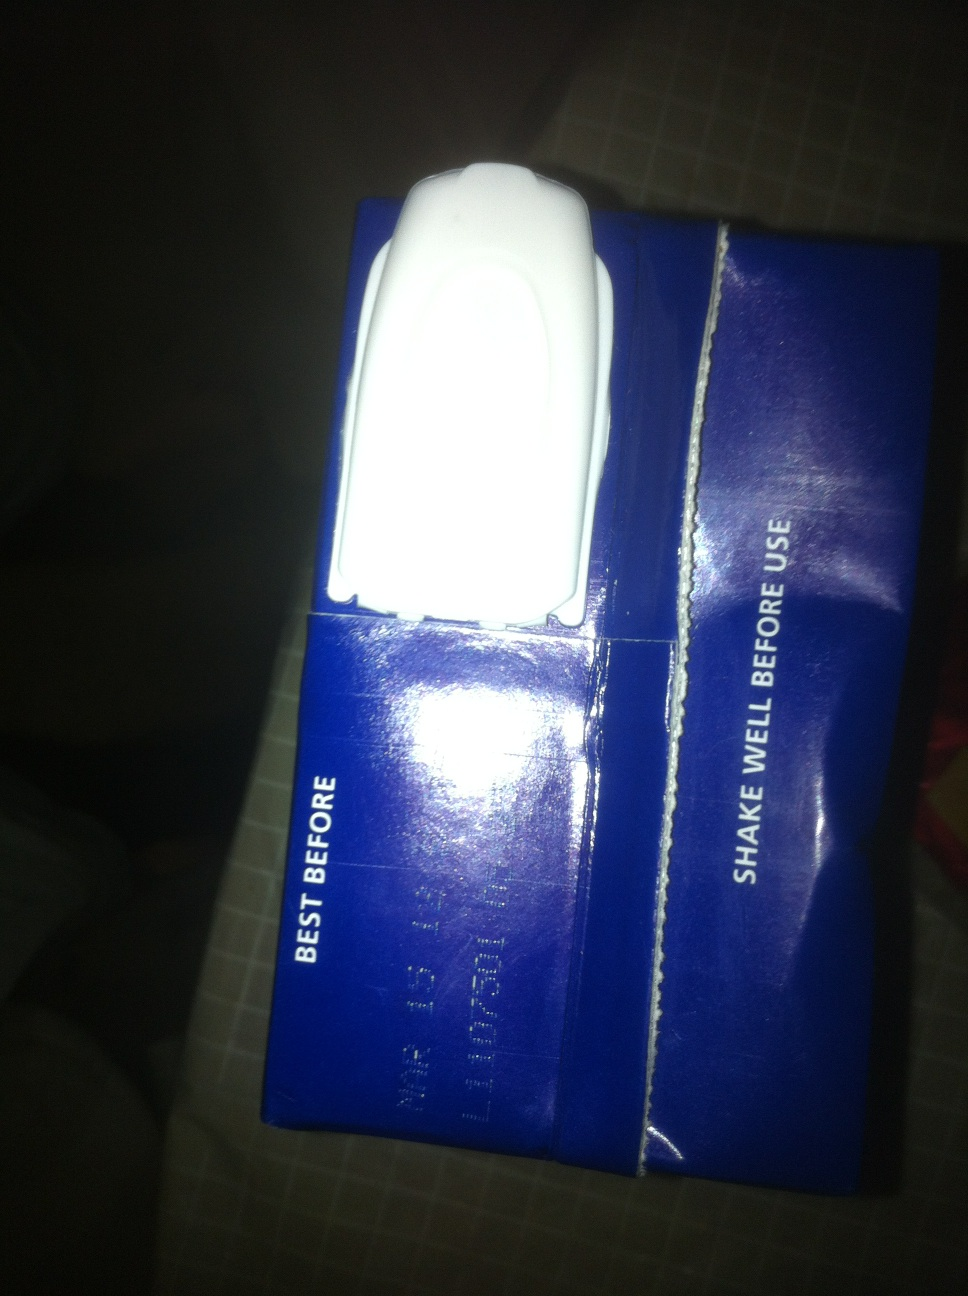Is that better? What is the expiration date now? The expiration date on the packaging is clearly visible as 'Best before: May 30, 2014'. It's important to check this date to ensure the product's freshness and safety for use. 